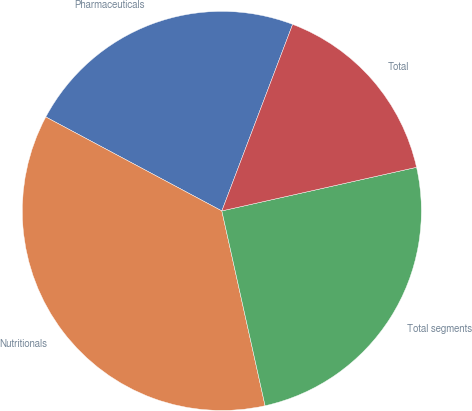Convert chart. <chart><loc_0><loc_0><loc_500><loc_500><pie_chart><fcel>Pharmaceuticals<fcel>Nutritionals<fcel>Total segments<fcel>Total<nl><fcel>22.97%<fcel>36.28%<fcel>25.03%<fcel>15.72%<nl></chart> 